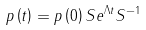Convert formula to latex. <formula><loc_0><loc_0><loc_500><loc_500>p \left ( t \right ) = p \left ( 0 \right ) S e ^ { \Lambda t } S ^ { - 1 }</formula> 